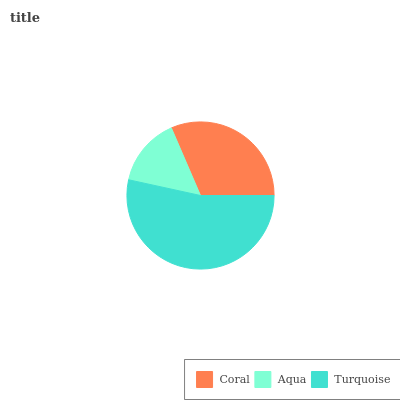Is Aqua the minimum?
Answer yes or no. Yes. Is Turquoise the maximum?
Answer yes or no. Yes. Is Turquoise the minimum?
Answer yes or no. No. Is Aqua the maximum?
Answer yes or no. No. Is Turquoise greater than Aqua?
Answer yes or no. Yes. Is Aqua less than Turquoise?
Answer yes or no. Yes. Is Aqua greater than Turquoise?
Answer yes or no. No. Is Turquoise less than Aqua?
Answer yes or no. No. Is Coral the high median?
Answer yes or no. Yes. Is Coral the low median?
Answer yes or no. Yes. Is Aqua the high median?
Answer yes or no. No. Is Aqua the low median?
Answer yes or no. No. 